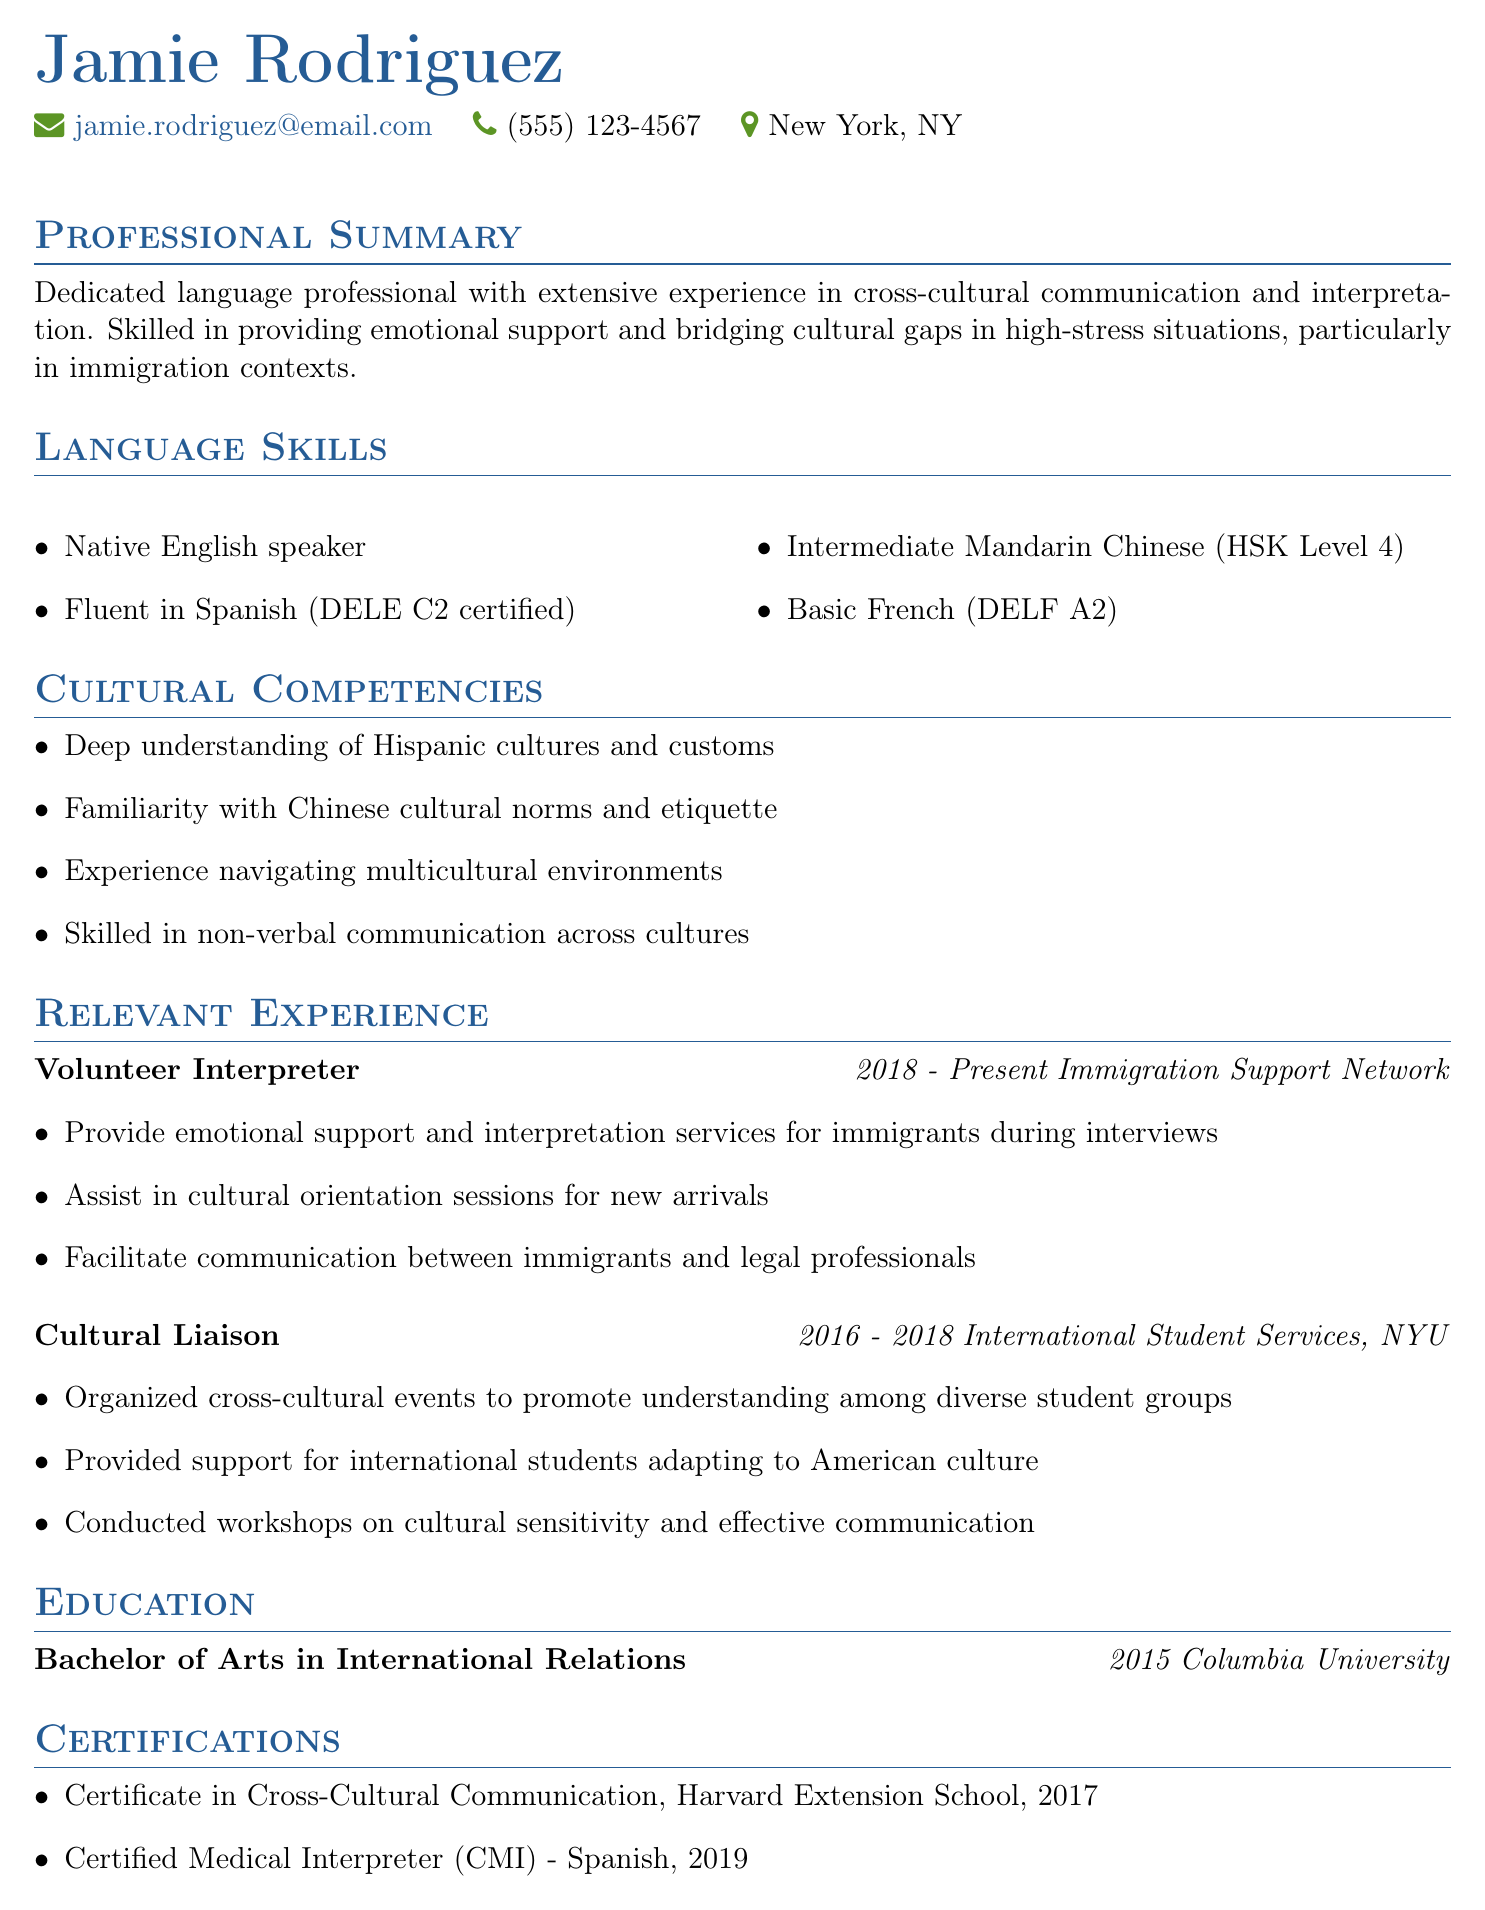What is Jamie Rodriguez's email? The email for Jamie Rodriguez is provided in the personal information section of the document.
Answer: jamie.rodriguez@email.com What degree does Jamie Rodriguez hold? The degree is listed under the education section of the document.
Answer: Bachelor of Arts in International Relations Which organization did Jamie work for as a Cultural Liaison? The organization name is given in the relevant experience section specific to that role.
Answer: International Student Services, NYU How many language skills are listed? The number of language skills can be counted from the language skills section of the document.
Answer: 4 What certification did Jamie obtain in 2019? This certification is mentioned specifically in the certifications section of the resume.
Answer: Certified Medical Interpreter (CMI) - Spanish What is Jamie's location? The location is specified in the personal information section of the document.
Answer: New York, NY In which year did Jamie graduate? The graduation year is noted in the education section.
Answer: 2015 What cultural competency related to Hispanic cultures is mentioned? A specific cultural competency is provided in the cultural competencies section of the document.
Answer: Deep understanding of Hispanic cultures and customs What role has Jamie held since 2018? The role is stated in the relevant experience section with the corresponding duration.
Answer: Volunteer Interpreter 